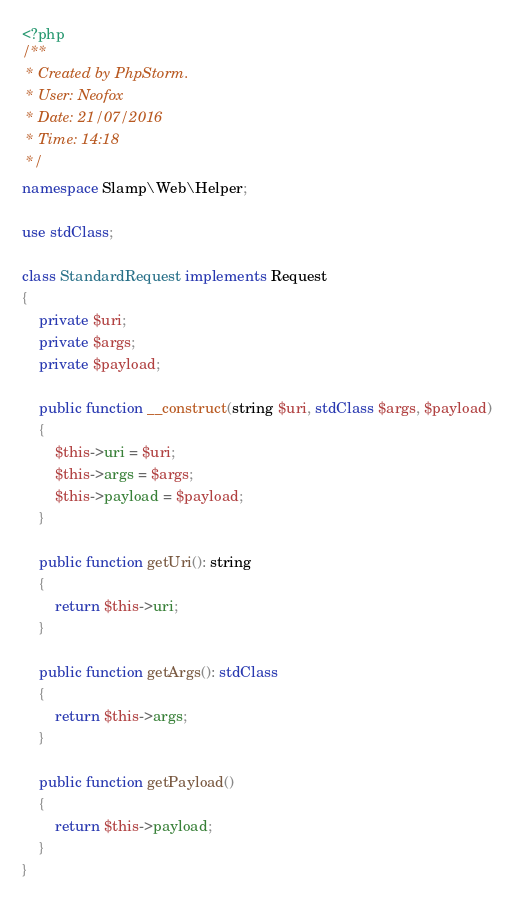Convert code to text. <code><loc_0><loc_0><loc_500><loc_500><_PHP_><?php
/**
 * Created by PhpStorm.
 * User: Neofox
 * Date: 21/07/2016
 * Time: 14:18
 */
namespace Slamp\Web\Helper;

use stdClass;

class StandardRequest implements Request
{
    private $uri;
    private $args;
    private $payload;

    public function __construct(string $uri, stdClass $args, $payload)
    {
        $this->uri = $uri;
        $this->args = $args;
        $this->payload = $payload;
    }

    public function getUri(): string
    {
        return $this->uri;
    }

    public function getArgs(): stdClass
    {
        return $this->args;
    }

    public function getPayload()
    {
        return $this->payload;
    }
}</code> 